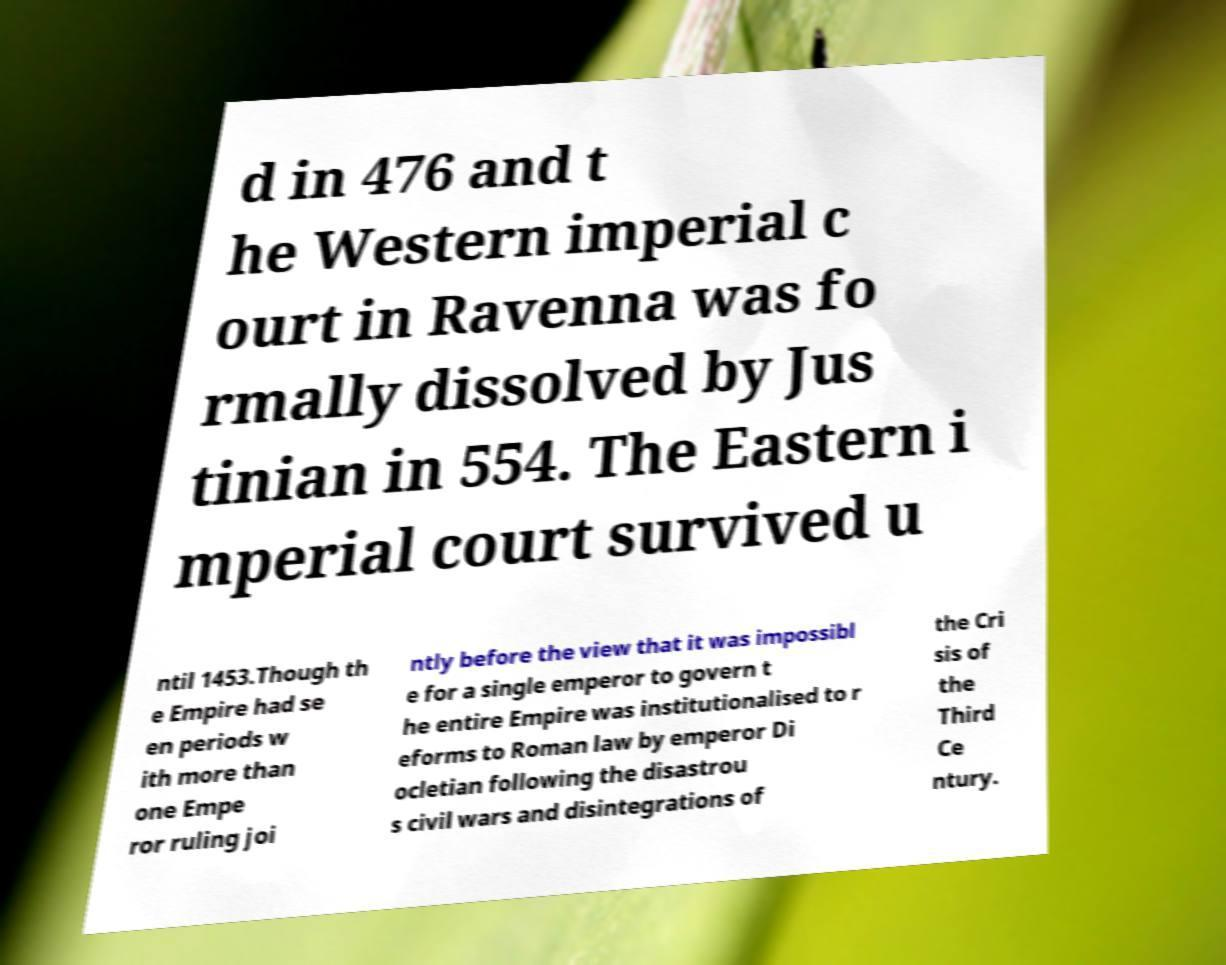Could you extract and type out the text from this image? d in 476 and t he Western imperial c ourt in Ravenna was fo rmally dissolved by Jus tinian in 554. The Eastern i mperial court survived u ntil 1453.Though th e Empire had se en periods w ith more than one Empe ror ruling joi ntly before the view that it was impossibl e for a single emperor to govern t he entire Empire was institutionalised to r eforms to Roman law by emperor Di ocletian following the disastrou s civil wars and disintegrations of the Cri sis of the Third Ce ntury. 